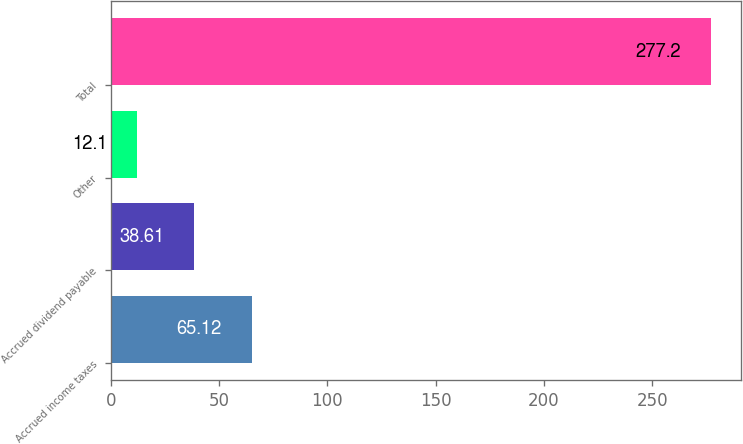Convert chart to OTSL. <chart><loc_0><loc_0><loc_500><loc_500><bar_chart><fcel>Accrued income taxes<fcel>Accrued dividend payable<fcel>Other<fcel>Total<nl><fcel>65.12<fcel>38.61<fcel>12.1<fcel>277.2<nl></chart> 